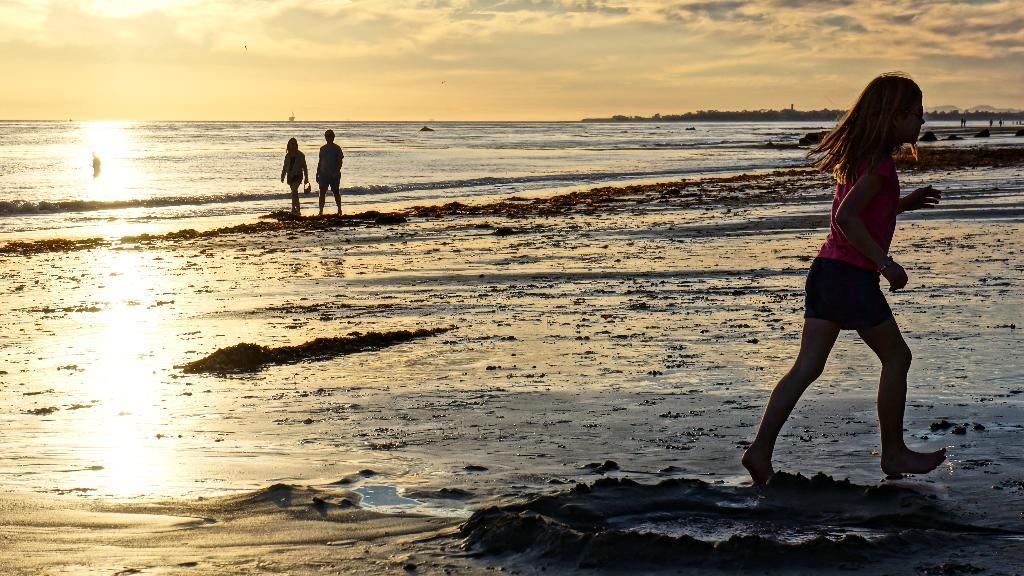In one or two sentences, can you explain what this image depicts? Here we can see three persons. This is water. In the background we can see trees and sky with clouds. 